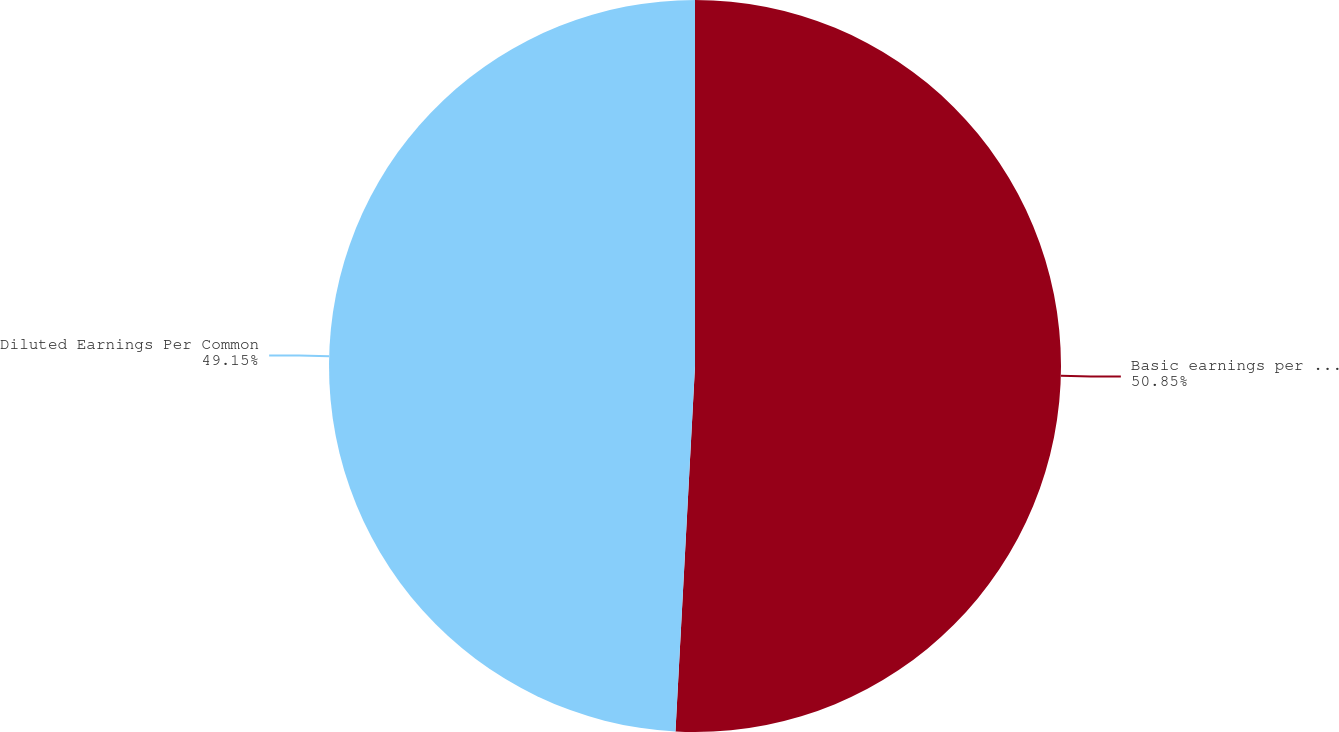Convert chart. <chart><loc_0><loc_0><loc_500><loc_500><pie_chart><fcel>Basic earnings per common<fcel>Diluted Earnings Per Common<nl><fcel>50.85%<fcel>49.15%<nl></chart> 